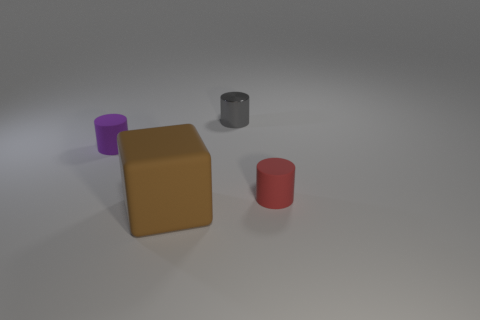Subtract all small gray metal cylinders. How many cylinders are left? 2 Add 1 large brown cubes. How many objects exist? 5 Subtract all cylinders. How many objects are left? 1 Subtract 2 cylinders. How many cylinders are left? 1 Subtract all purple cylinders. How many cylinders are left? 2 Subtract 0 blue spheres. How many objects are left? 4 Subtract all purple cylinders. Subtract all cyan blocks. How many cylinders are left? 2 Subtract all big purple metallic balls. Subtract all brown rubber cubes. How many objects are left? 3 Add 1 big brown matte things. How many big brown matte things are left? 2 Add 3 large brown things. How many large brown things exist? 4 